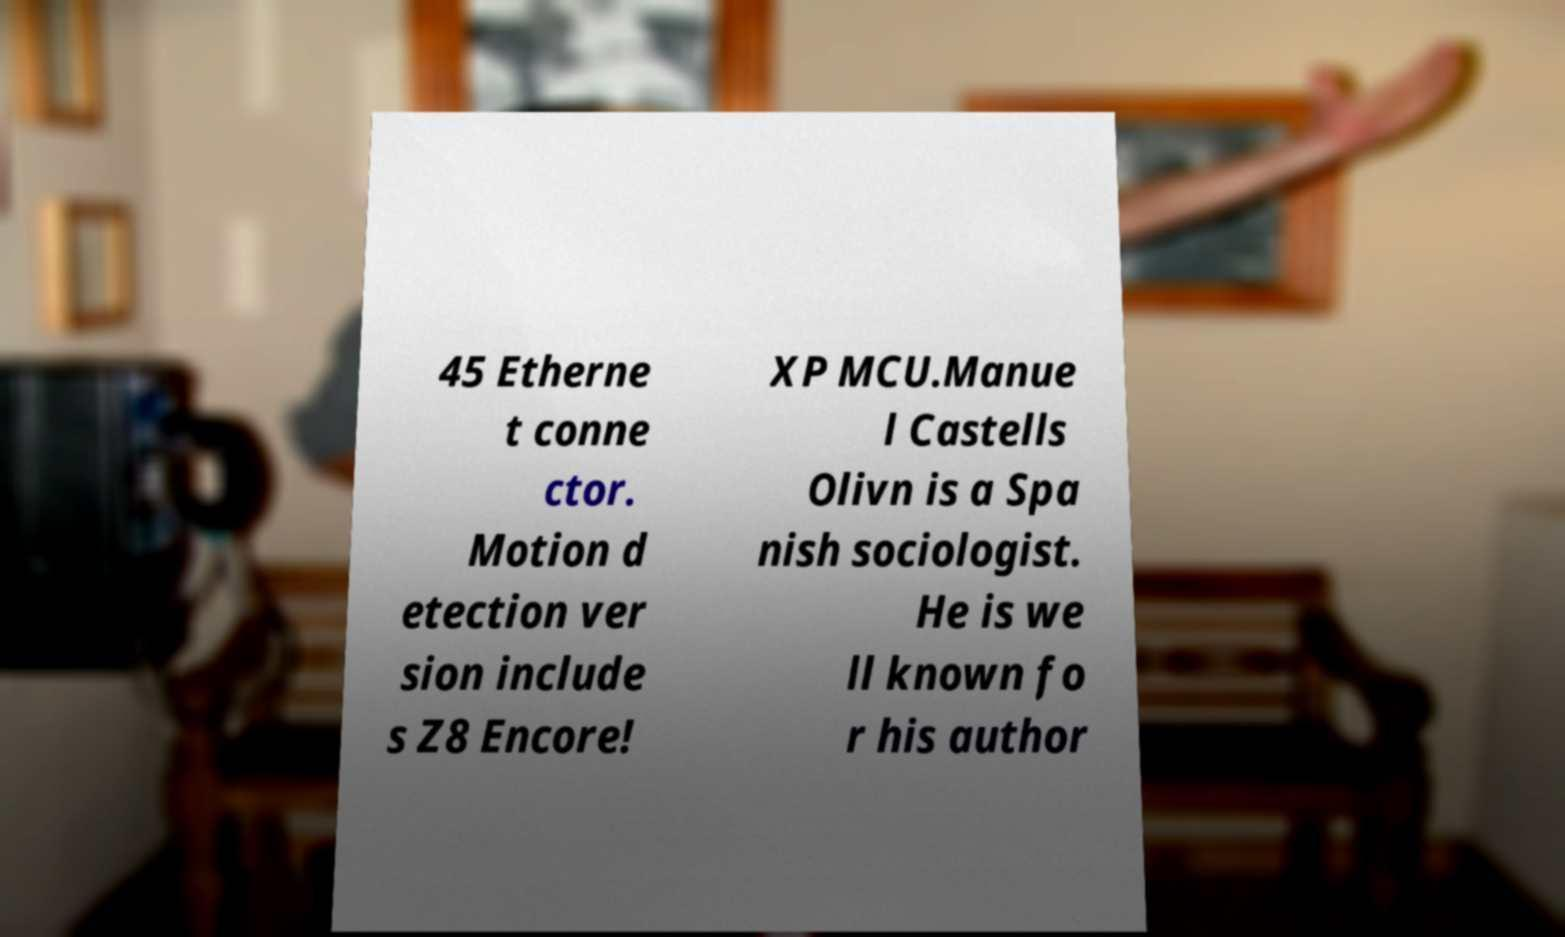Please read and relay the text visible in this image. What does it say? 45 Etherne t conne ctor. Motion d etection ver sion include s Z8 Encore! XP MCU.Manue l Castells Olivn is a Spa nish sociologist. He is we ll known fo r his author 